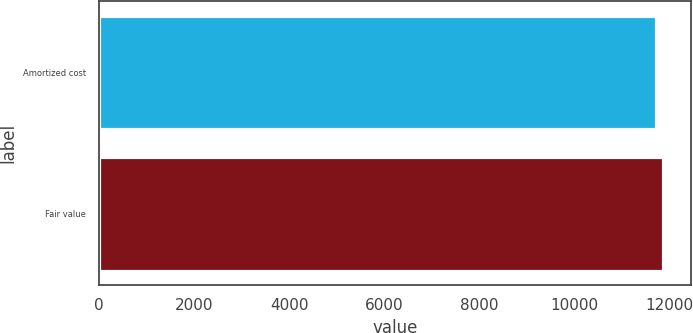Convert chart to OTSL. <chart><loc_0><loc_0><loc_500><loc_500><bar_chart><fcel>Amortized cost<fcel>Fair value<nl><fcel>11731<fcel>11864<nl></chart> 